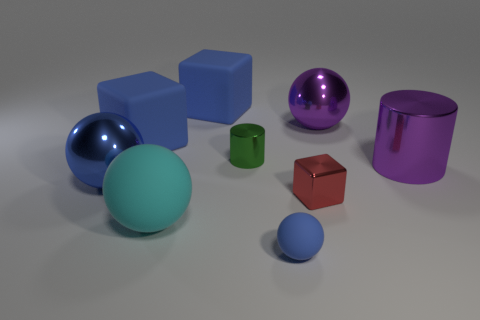Are there more green objects than blue spheres?
Provide a short and direct response. No. Is there anything else that is the same color as the big metallic cylinder?
Provide a short and direct response. Yes. Do the cyan object and the tiny sphere have the same material?
Offer a terse response. Yes. Are there fewer large purple metallic balls than large brown metal spheres?
Make the answer very short. No. Does the big blue metal object have the same shape as the cyan rubber object?
Offer a terse response. Yes. The large cylinder is what color?
Provide a short and direct response. Purple. What number of other objects are the same material as the large purple sphere?
Provide a short and direct response. 4. How many yellow things are small rubber things or metal cylinders?
Offer a very short reply. 0. There is a tiny metal object behind the metal block; does it have the same shape as the purple shiny object that is left of the big cylinder?
Your answer should be very brief. No. There is a small matte ball; is its color the same as the large matte thing in front of the blue metallic sphere?
Provide a succinct answer. No. 